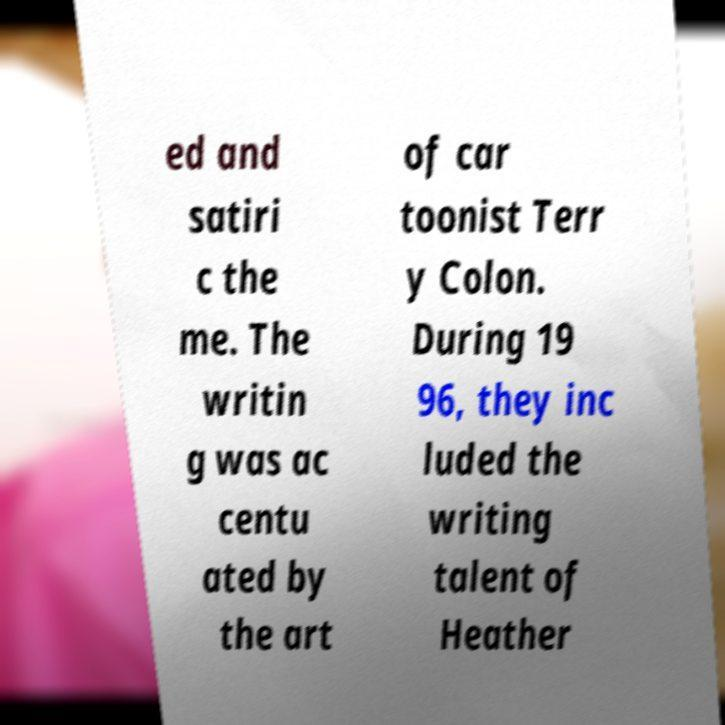Could you extract and type out the text from this image? ed and satiri c the me. The writin g was ac centu ated by the art of car toonist Terr y Colon. During 19 96, they inc luded the writing talent of Heather 